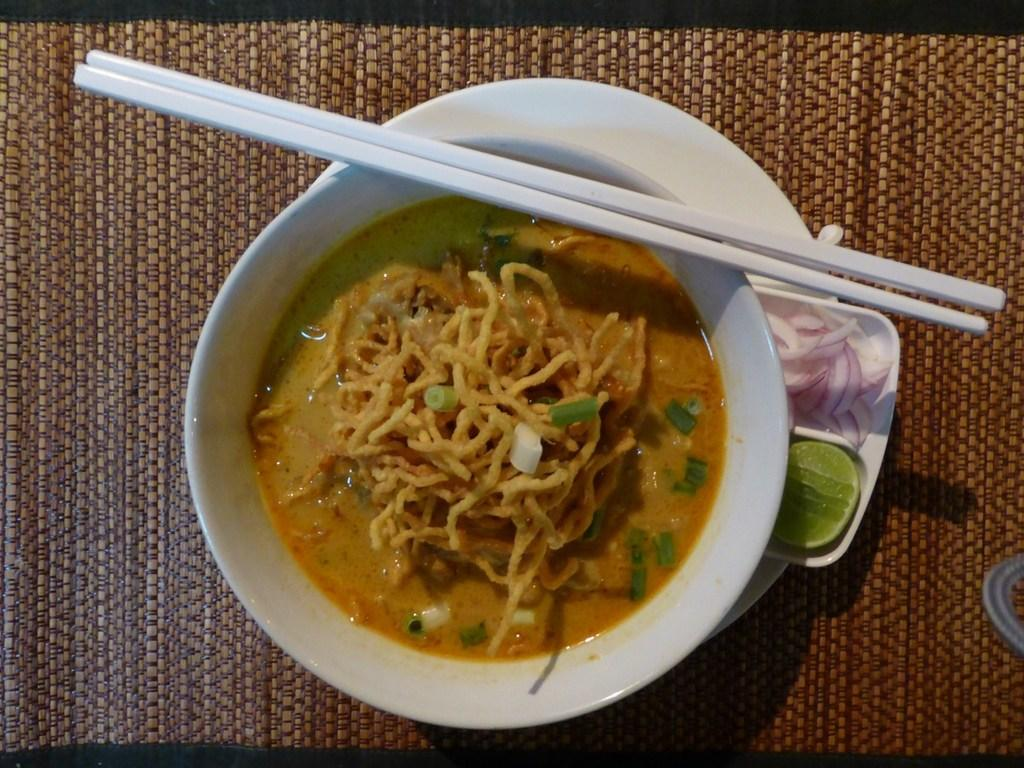What is in the bowl that is visible in the image? There is food in a bowl in the image. What utensil is visible in the image? Chopsticks are visible in the image. What is another dish present in the image? There is a plate in the image. What type of vegetable can be seen in the image? Onions are present in the image. What type of fruit is visible in the image? A lemon is visible in the image. What type of book is visible in the image? There is no book present in the image. What is the source of the steam in the image? There is no steam present in the image. 